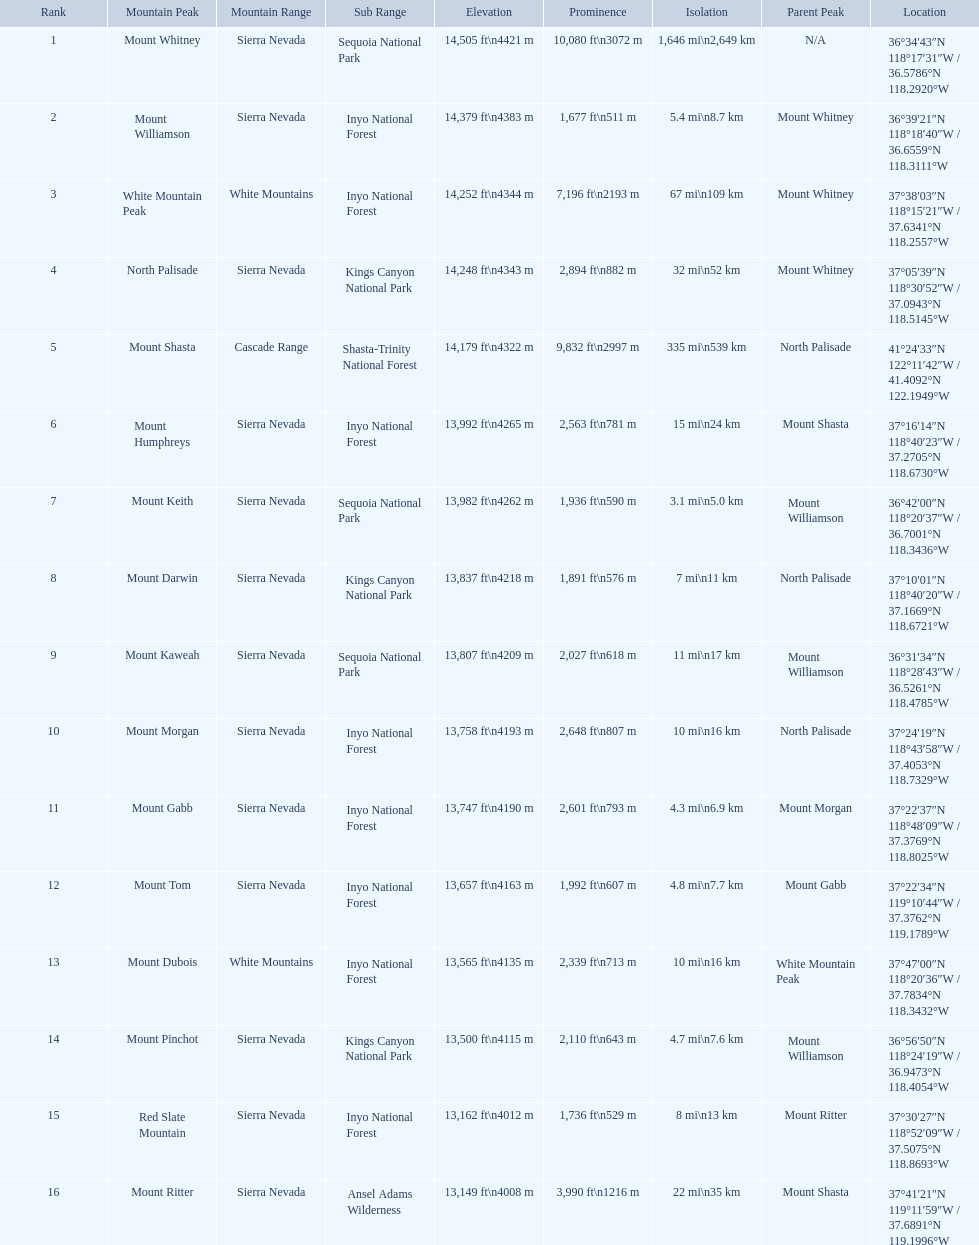What are all of the mountain peaks? Mount Whitney, Mount Williamson, White Mountain Peak, North Palisade, Mount Shasta, Mount Humphreys, Mount Keith, Mount Darwin, Mount Kaweah, Mount Morgan, Mount Gabb, Mount Tom, Mount Dubois, Mount Pinchot, Red Slate Mountain, Mount Ritter. In what ranges are they? Sierra Nevada, Sierra Nevada, White Mountains, Sierra Nevada, Cascade Range, Sierra Nevada, Sierra Nevada, Sierra Nevada, Sierra Nevada, Sierra Nevada, Sierra Nevada, Sierra Nevada, White Mountains, Sierra Nevada, Sierra Nevada, Sierra Nevada. Which peak is in the cascade range? Mount Shasta. 